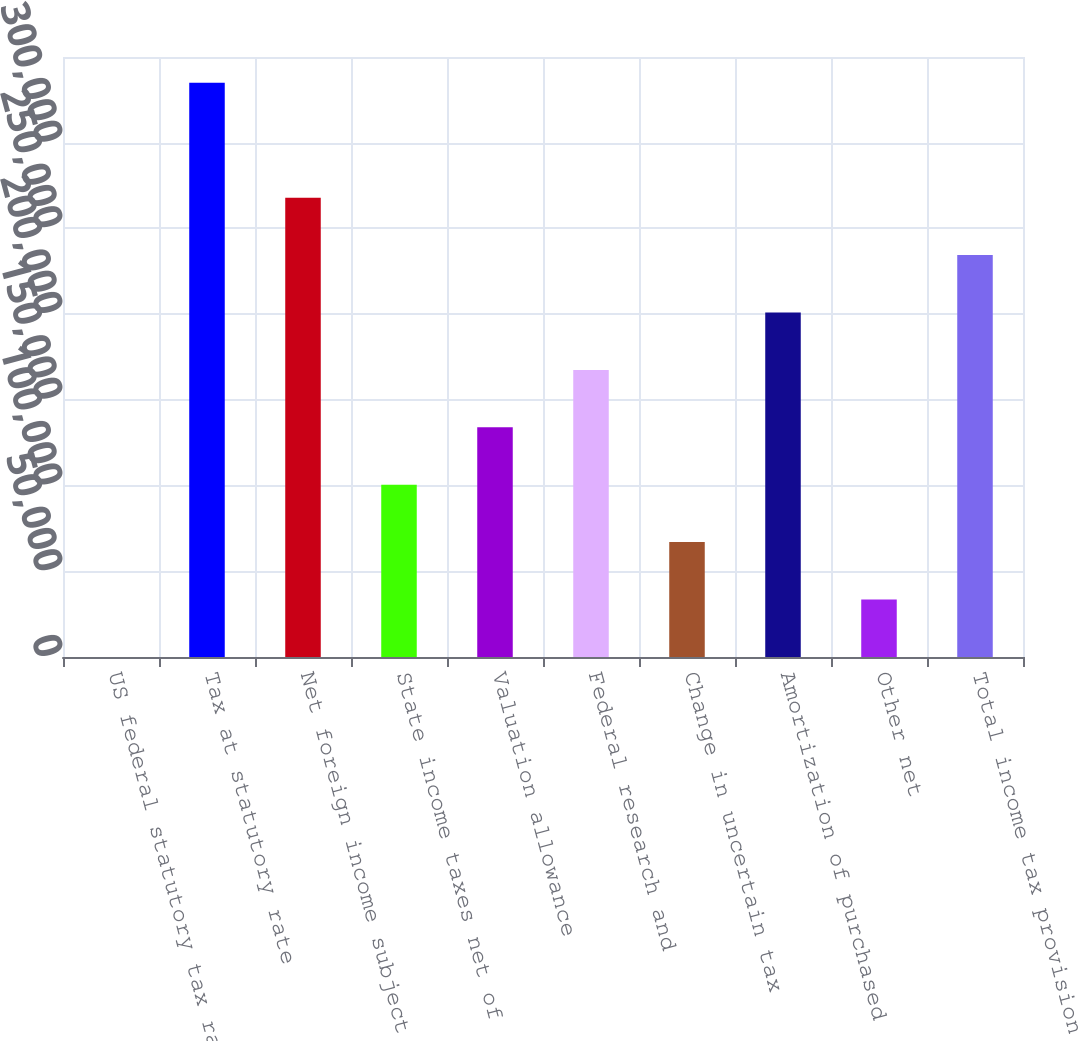<chart> <loc_0><loc_0><loc_500><loc_500><bar_chart><fcel>US federal statutory tax rate<fcel>Tax at statutory rate<fcel>Net foreign income subject to<fcel>State income taxes net of<fcel>Valuation allowance<fcel>Federal research and<fcel>Change in uncertain tax<fcel>Amortization of purchased<fcel>Other net<fcel>Total income tax provision<nl><fcel>35<fcel>334922<fcel>267945<fcel>100501<fcel>133990<fcel>167478<fcel>67012.4<fcel>200967<fcel>33523.7<fcel>234456<nl></chart> 